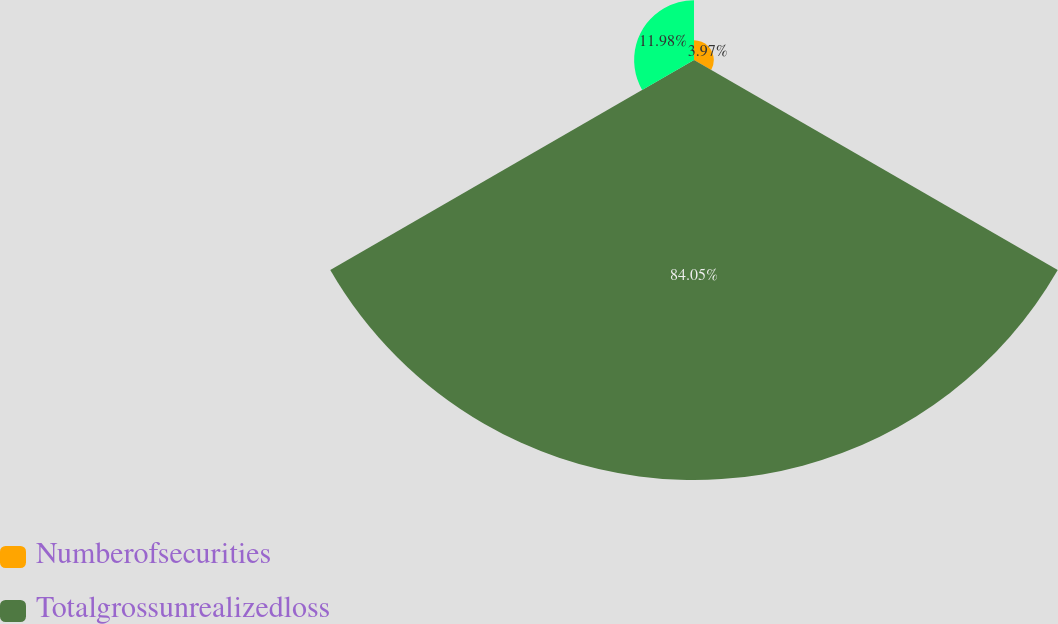Convert chart to OTSL. <chart><loc_0><loc_0><loc_500><loc_500><pie_chart><fcel>Numberofsecurities<fcel>Totalgrossunrealizedloss<fcel>Unnamed: 2<nl><fcel>3.97%<fcel>84.05%<fcel>11.98%<nl></chart> 